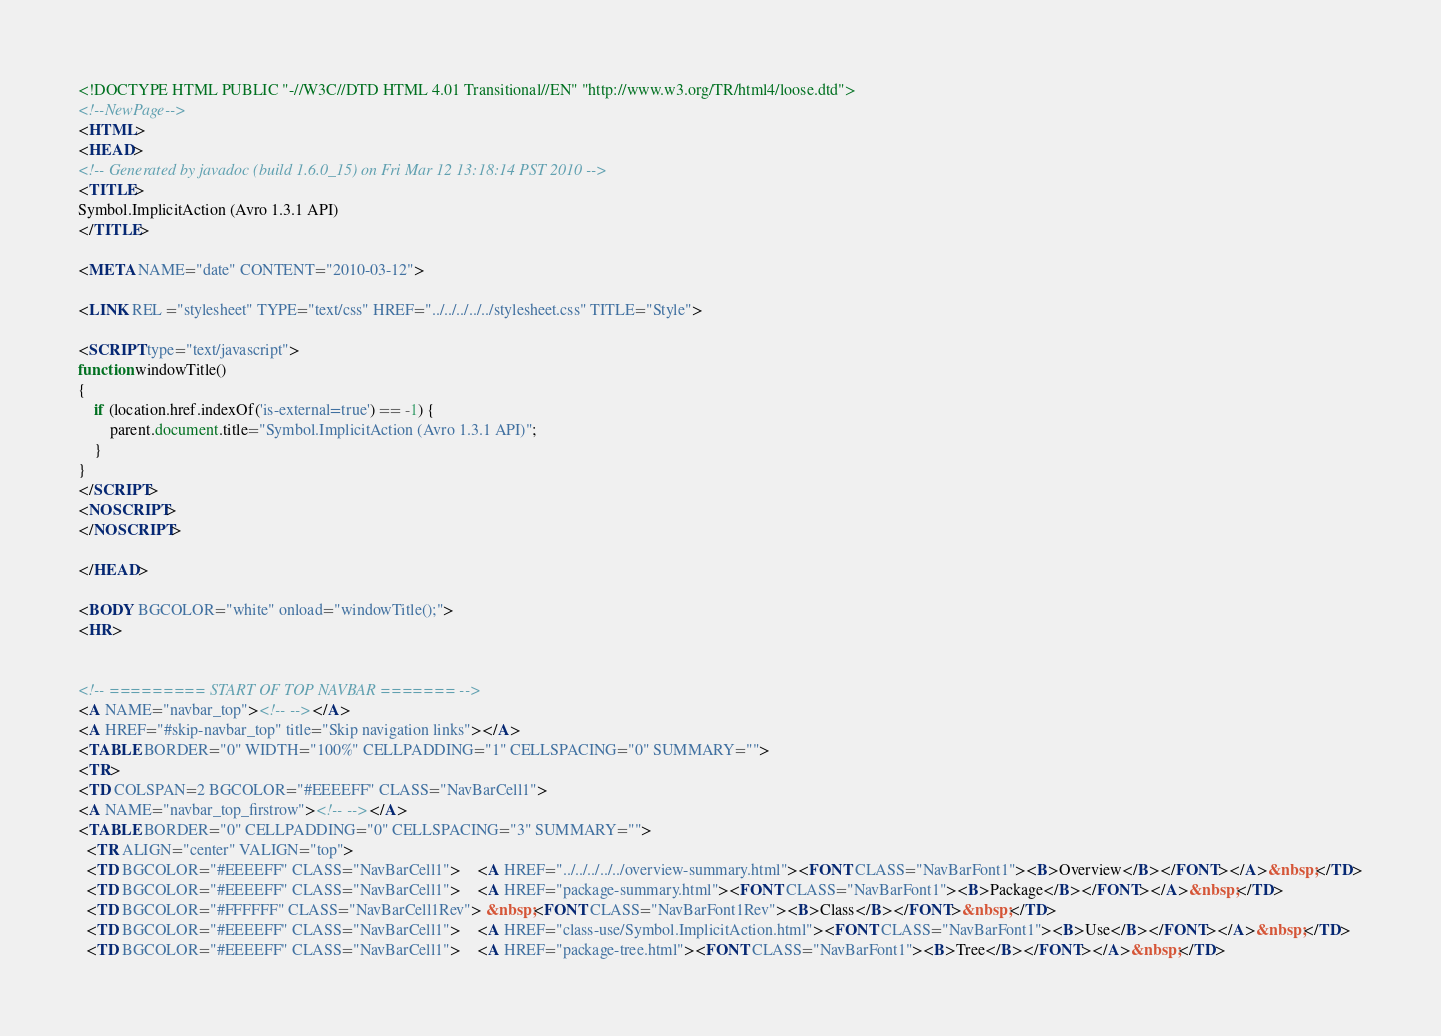<code> <loc_0><loc_0><loc_500><loc_500><_HTML_><!DOCTYPE HTML PUBLIC "-//W3C//DTD HTML 4.01 Transitional//EN" "http://www.w3.org/TR/html4/loose.dtd">
<!--NewPage-->
<HTML>
<HEAD>
<!-- Generated by javadoc (build 1.6.0_15) on Fri Mar 12 13:18:14 PST 2010 -->
<TITLE>
Symbol.ImplicitAction (Avro 1.3.1 API)
</TITLE>

<META NAME="date" CONTENT="2010-03-12">

<LINK REL ="stylesheet" TYPE="text/css" HREF="../../../../../stylesheet.css" TITLE="Style">

<SCRIPT type="text/javascript">
function windowTitle()
{
    if (location.href.indexOf('is-external=true') == -1) {
        parent.document.title="Symbol.ImplicitAction (Avro 1.3.1 API)";
    }
}
</SCRIPT>
<NOSCRIPT>
</NOSCRIPT>

</HEAD>

<BODY BGCOLOR="white" onload="windowTitle();">
<HR>


<!-- ========= START OF TOP NAVBAR ======= -->
<A NAME="navbar_top"><!-- --></A>
<A HREF="#skip-navbar_top" title="Skip navigation links"></A>
<TABLE BORDER="0" WIDTH="100%" CELLPADDING="1" CELLSPACING="0" SUMMARY="">
<TR>
<TD COLSPAN=2 BGCOLOR="#EEEEFF" CLASS="NavBarCell1">
<A NAME="navbar_top_firstrow"><!-- --></A>
<TABLE BORDER="0" CELLPADDING="0" CELLSPACING="3" SUMMARY="">
  <TR ALIGN="center" VALIGN="top">
  <TD BGCOLOR="#EEEEFF" CLASS="NavBarCell1">    <A HREF="../../../../../overview-summary.html"><FONT CLASS="NavBarFont1"><B>Overview</B></FONT></A>&nbsp;</TD>
  <TD BGCOLOR="#EEEEFF" CLASS="NavBarCell1">    <A HREF="package-summary.html"><FONT CLASS="NavBarFont1"><B>Package</B></FONT></A>&nbsp;</TD>
  <TD BGCOLOR="#FFFFFF" CLASS="NavBarCell1Rev"> &nbsp;<FONT CLASS="NavBarFont1Rev"><B>Class</B></FONT>&nbsp;</TD>
  <TD BGCOLOR="#EEEEFF" CLASS="NavBarCell1">    <A HREF="class-use/Symbol.ImplicitAction.html"><FONT CLASS="NavBarFont1"><B>Use</B></FONT></A>&nbsp;</TD>
  <TD BGCOLOR="#EEEEFF" CLASS="NavBarCell1">    <A HREF="package-tree.html"><FONT CLASS="NavBarFont1"><B>Tree</B></FONT></A>&nbsp;</TD></code> 